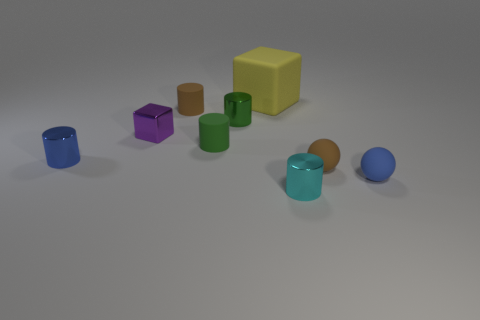Are there the same number of metallic cubes on the right side of the small purple thing and tiny brown rubber objects in front of the brown rubber cylinder?
Make the answer very short. No. Are there any other things that have the same material as the brown sphere?
Give a very brief answer. Yes. What color is the small matte cylinder that is in front of the small purple shiny block?
Provide a short and direct response. Green. Is the number of small metal things to the left of the large yellow thing the same as the number of small brown matte balls?
Offer a very short reply. No. How many other objects are the same shape as the big yellow rubber thing?
Ensure brevity in your answer.  1. How many things are in front of the yellow block?
Your answer should be very brief. 8. There is a cylinder that is both behind the tiny purple block and right of the tiny green rubber cylinder; how big is it?
Your response must be concise. Small. Are there any big cyan metal things?
Make the answer very short. No. What number of other things are there of the same size as the blue metal cylinder?
Provide a succinct answer. 7. Is the color of the small metallic cylinder that is left of the green rubber object the same as the small shiny cylinder that is right of the tiny green shiny cylinder?
Your response must be concise. No. 